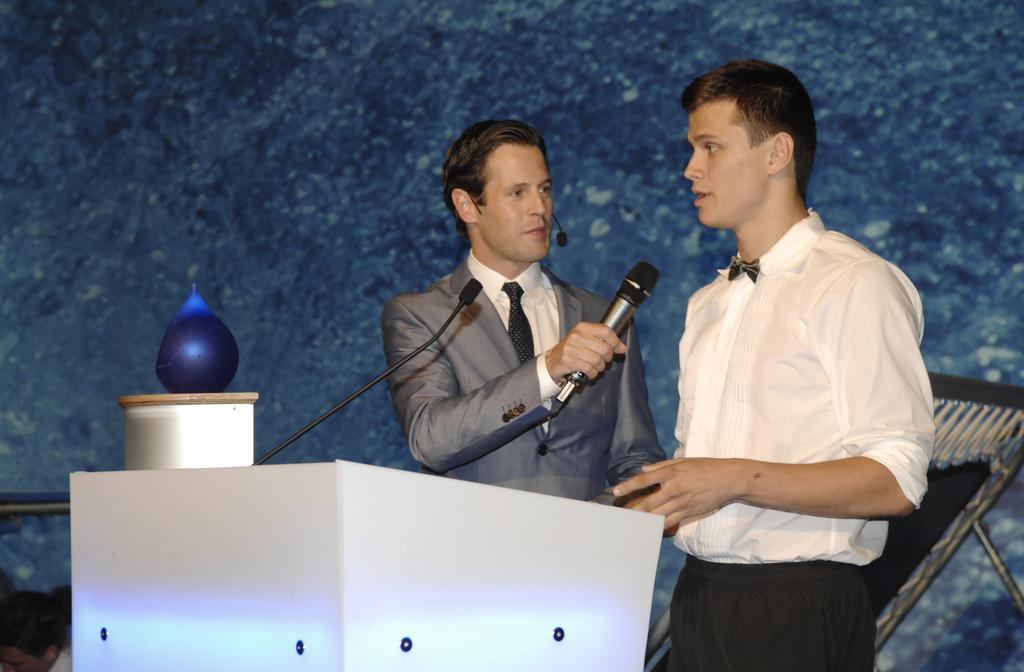How many people are in the image? There are two people in the image. What is one person holding in the image? One person is holding a mic. What can be seen behind the people in the image? The people are standing in front of a podium. What type of bear can be seen joining the people on stage in the image? There is no bear present in the image, and therefore no such activity can be observed. 